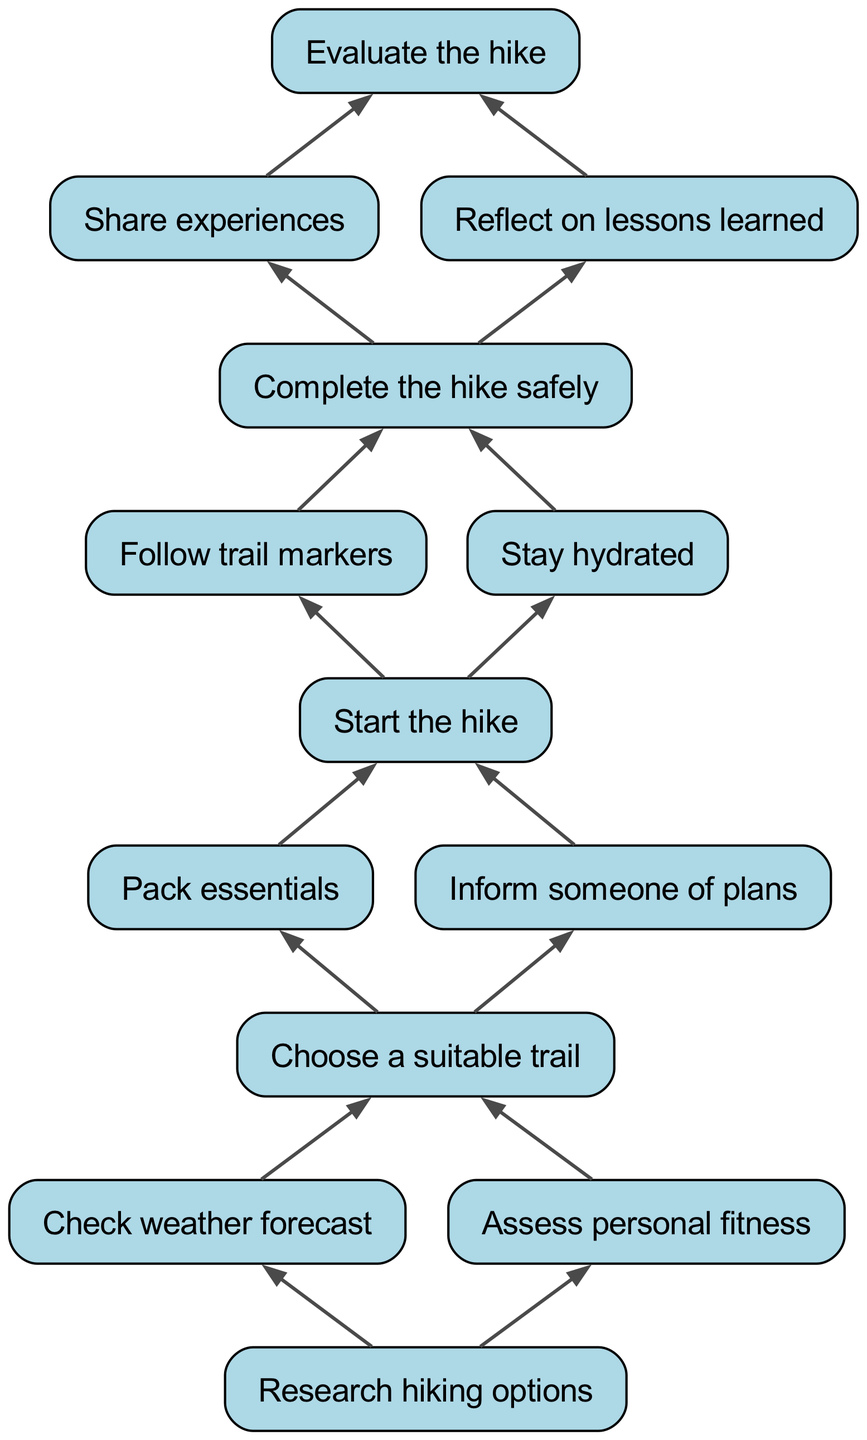What is the last step in the diagram? The last step in the diagram is "Research hiking options." This can be found at the bottom of the flow chart, as it is the final node with no children.
Answer: Research hiking options How many steps are there before starting the hike? To identify the steps before starting the hike, we track the nodes leading to "Start the hike." There are three steps before it: "Pack essentials," "Inform someone of plans," and "Choose a suitable trail." Therefore, the answer is four total steps including "Choose a suitable trail."
Answer: Four What does "Evaluate the hike" lead to? "Evaluate the hike" leads to two nodes: "Share experiences" and "Reflect on lessons learned." Both of these are direct children of the "Evaluate the hike" node in the diagram.
Answer: Share experiences and Reflect on lessons learned How many child nodes does "Choose a suitable trail" have? "Choose a suitable trail" has two child nodes: "Check weather forecast" and "Assess personal fitness." This is determined by looking at the number of elements that directly branch off from "Choose a suitable trail."
Answer: Two What is required to complete the hike safely? To complete the hike safely, both "Follow trail markers" and "Stay hydrated" are required. This requirement shows that completing the hike safely involves two steps that act as children under the "Complete the hike safely" node.
Answer: Follow trail markers and Stay hydrated If "Check weather forecast" is done, what logical step follows? If "Check weather forecast" is completed, the next logical step is "Research hiking options." This is derived from the flow of the chart, where completing weather checks assists in making informed trail choices.
Answer: Research hiking options 